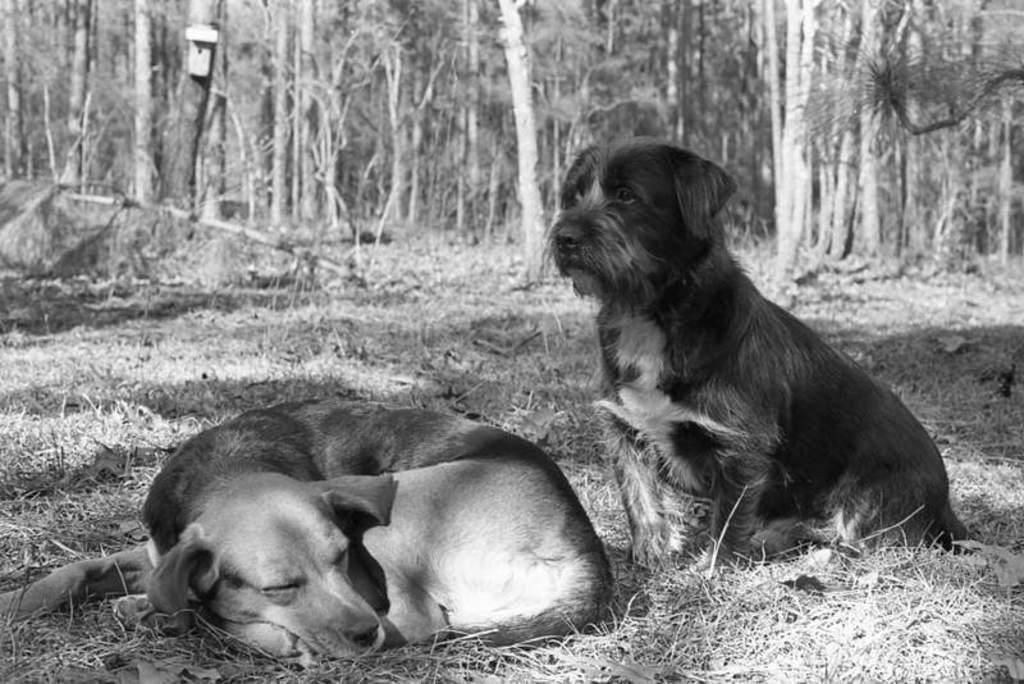Can you describe this image briefly? In this picture we can see two dogs, a dog on the left side is sleeping, a dog on the right side is sitting, at the bottom there is grass, we can see trees in the background. 